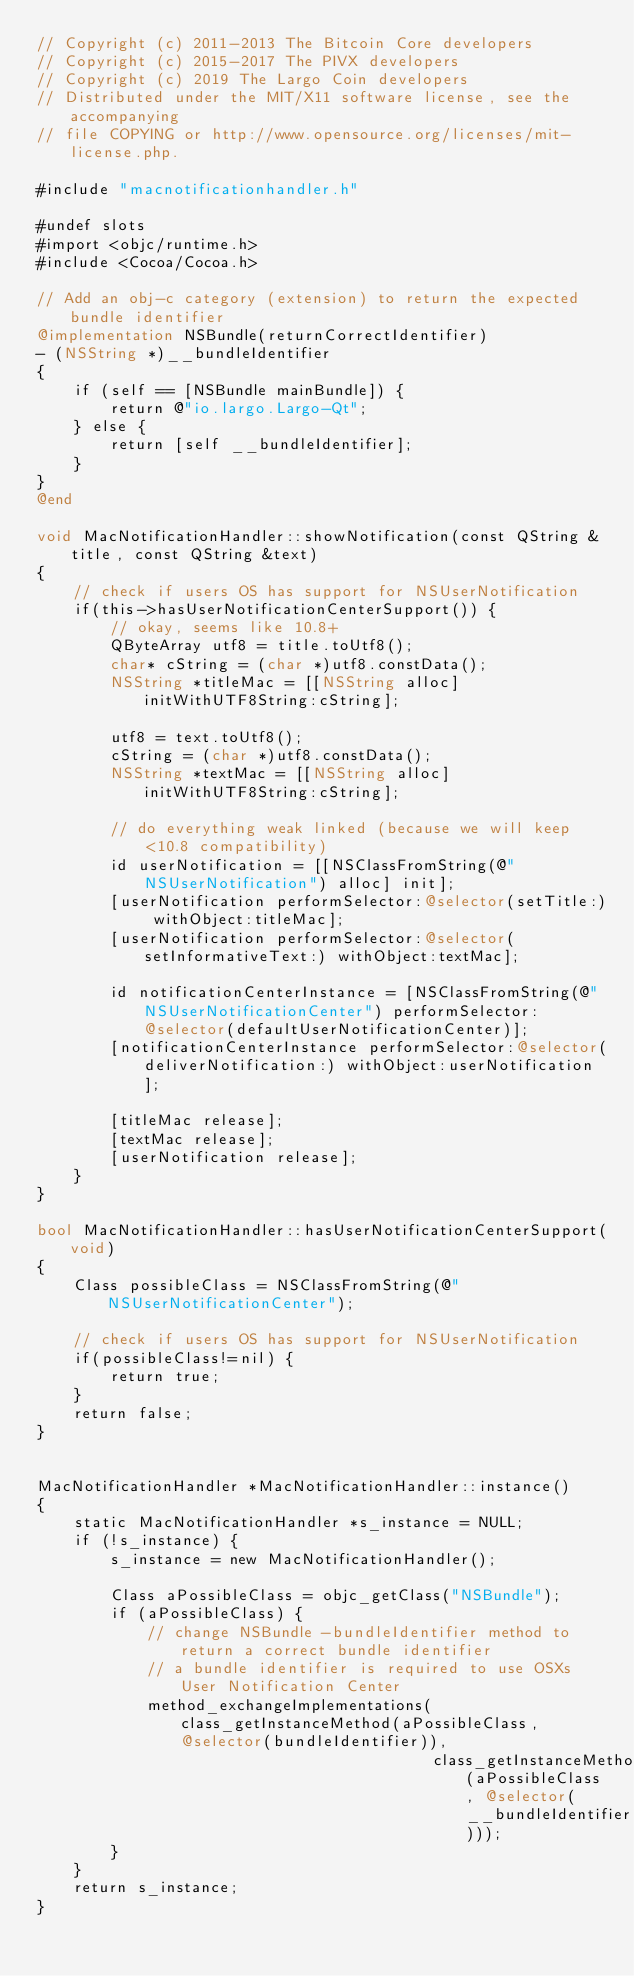<code> <loc_0><loc_0><loc_500><loc_500><_ObjectiveC_>// Copyright (c) 2011-2013 The Bitcoin Core developers
// Copyright (c) 2015-2017 The PIVX developers
// Copyright (c) 2019 The Largo Coin developers
// Distributed under the MIT/X11 software license, see the accompanying
// file COPYING or http://www.opensource.org/licenses/mit-license.php.

#include "macnotificationhandler.h"

#undef slots
#import <objc/runtime.h>
#include <Cocoa/Cocoa.h>

// Add an obj-c category (extension) to return the expected bundle identifier
@implementation NSBundle(returnCorrectIdentifier)
- (NSString *)__bundleIdentifier
{
    if (self == [NSBundle mainBundle]) {
        return @"io.largo.Largo-Qt";
    } else {
        return [self __bundleIdentifier];
    }
}
@end

void MacNotificationHandler::showNotification(const QString &title, const QString &text)
{
    // check if users OS has support for NSUserNotification
    if(this->hasUserNotificationCenterSupport()) {
        // okay, seems like 10.8+
        QByteArray utf8 = title.toUtf8();
        char* cString = (char *)utf8.constData();
        NSString *titleMac = [[NSString alloc] initWithUTF8String:cString];

        utf8 = text.toUtf8();
        cString = (char *)utf8.constData();
        NSString *textMac = [[NSString alloc] initWithUTF8String:cString];

        // do everything weak linked (because we will keep <10.8 compatibility)
        id userNotification = [[NSClassFromString(@"NSUserNotification") alloc] init];
        [userNotification performSelector:@selector(setTitle:) withObject:titleMac];
        [userNotification performSelector:@selector(setInformativeText:) withObject:textMac];

        id notificationCenterInstance = [NSClassFromString(@"NSUserNotificationCenter") performSelector:@selector(defaultUserNotificationCenter)];
        [notificationCenterInstance performSelector:@selector(deliverNotification:) withObject:userNotification];

        [titleMac release];
        [textMac release];
        [userNotification release];
    }
}

bool MacNotificationHandler::hasUserNotificationCenterSupport(void)
{
    Class possibleClass = NSClassFromString(@"NSUserNotificationCenter");

    // check if users OS has support for NSUserNotification
    if(possibleClass!=nil) {
        return true;
    }
    return false;
}


MacNotificationHandler *MacNotificationHandler::instance()
{
    static MacNotificationHandler *s_instance = NULL;
    if (!s_instance) {
        s_instance = new MacNotificationHandler();
        
        Class aPossibleClass = objc_getClass("NSBundle");
        if (aPossibleClass) {
            // change NSBundle -bundleIdentifier method to return a correct bundle identifier
            // a bundle identifier is required to use OSXs User Notification Center
            method_exchangeImplementations(class_getInstanceMethod(aPossibleClass, @selector(bundleIdentifier)),
                                           class_getInstanceMethod(aPossibleClass, @selector(__bundleIdentifier)));
        }
    }
    return s_instance;
}
</code> 